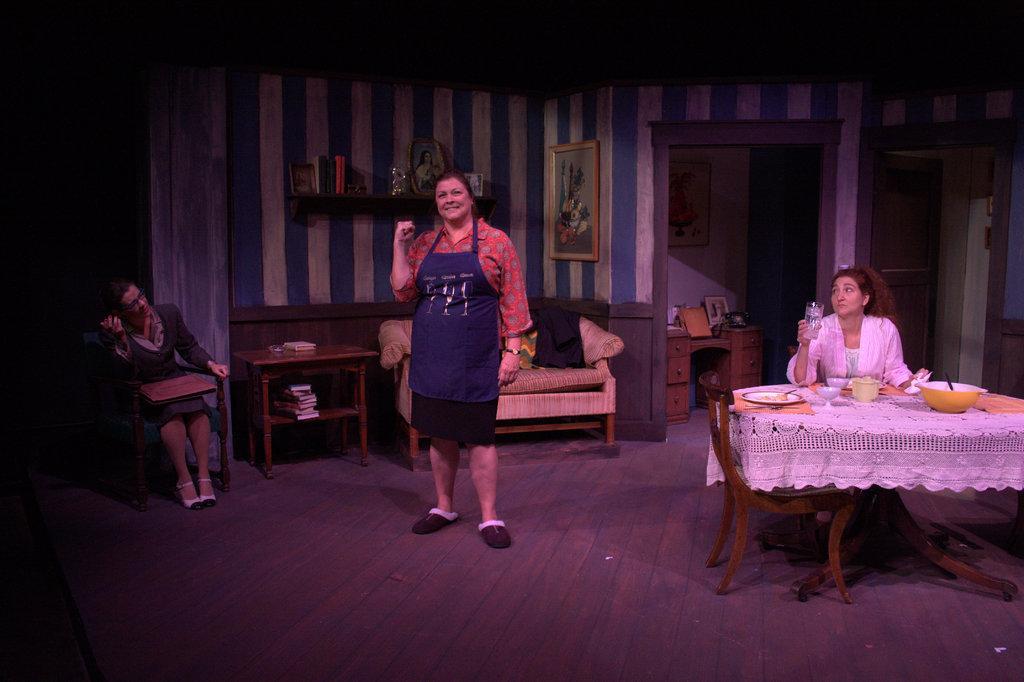How would you summarize this image in a sentence or two? In this image there is a woman standing and in back ground there is another woman , chair , table , frame attached to wall , couch , books , another person sitting in chair. 